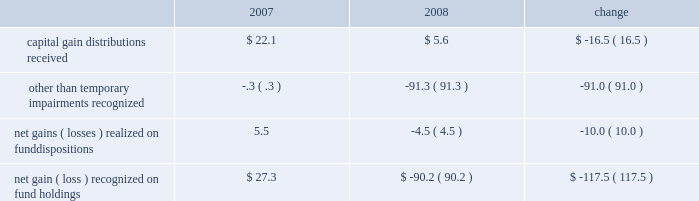Investment advisory revenues earned on the other investment portfolios that we manage decreased $ 3.6 million to $ 522.2 million .
Average assets in these portfolios were $ 142.1 billion during 2008 , up slightly from $ 141.4 billion in 2007 .
These minor changes , each less than 1% ( 1 % ) , are attributable to the timing of declining equity market valuations and cash flows among our separate account and sub-advised portfolios .
Net inflows , primarily from institutional investors , were $ 13.2 billion during 2008 , including the $ 1.3 billion transferred from the retirement funds to target-date trusts .
Decreases in market valuations , net of income , lowered our assets under management in these portfolios by $ 55.3 billion during 2008 .
Administrative fees increased $ 5.8 million to $ 353.9 million , primarily from increased costs of servicing activities for the mutual funds and their investors .
Changes in administrative fees are generally offset by similar changes in related operating expenses that are incurred to provide services to the funds and their investors .
Our largest expense , compensation and related costs , increased $ 18.4 million or 2.3% ( 2.3 % ) from 2007 .
This increase includes $ 37.2 million in salaries resulting from an 8.4% ( 8.4 % ) increase in our average staff count and an increase of our associates 2019 base salaries at the beginning of the year .
At december 31 , 2008 , we employed 5385 associates , up 6.0% ( 6.0 % ) from the end of 2007 , primarily to add capabilities and support increased volume-related activities and other growth over the past few years .
Over the course of 2008 , we slowed the growth of our associate base from earlier plans and the prior year .
We do not expect the number of our associates to increase in 2009 .
We also reduced our annual bonuses $ 27.6 million versus the 2007 year in response to recent and ongoing unfavorable financial market conditions that negatively impacted our operating results .
The balance of the increase is attributable to higher employee benefits and employment- related expenses , including an increase of $ 5.7 million in stock-based compensation .
Entering 2009 , we did not increase the salaries of our highest paid associates .
After higher spending during the first quarter of 2008 versus 2007 , investor sentiment in the uncertain and volatile market environment caused us to reduce advertising and promotion spending , which for the year was down $ 3.8 million from 2007 .
We expect to reduce these expenditures for 2009 versus 2008 , and estimate that spending in the first quarter of 2009 will be down about $ 5 million from the fourth quarter of 2008 .
We vary our level of spending based on market conditions and investor demand as well as our efforts to expand our investor base in the united states and abroad .
Occupancy and facility costs together with depreciation expense increased $ 18 million , or 12% ( 12 % ) compared to 2007 .
We have been expanding and renovating our facilities to accommodate the growth in our associates to meet business demands .
Other operating expenses were up $ 3.3 million from 2007 .
We increased our spending $ 9.8 million , primarily for professional fees and information and other third-party services .
Reductions in travel and charitable contributions partially offset these increases .
Our non-operating investment activity resulted in a net loss of $ 52.3 million in 2008 as compared to a net gain of $ 80.4 million in 2007 .
This change of $ 132.7 million is primarily attributable to losses recognized in 2008 on our investments in sponsored mutual funds , which resulted from declines in financial market values during the year. .
We recognized other than temporary impairments of our investments in sponsored mutual funds because of declines in fair value below cost for an extended period .
The significant declines in fair value below cost that occurred in 2008 were generally attributable to the adverse and ongoing market conditions discussed in the background section on page 18 of this report .
See also the discussion on page 24 of critical accounting policies for other than temporary impairments of available-for-sale securities .
In addition , income from money market and bond fund holdings was $ 19.3 million lower than in 2007 due to the significantly lower interest rate environment of 2008 .
Lower interest rates also led to substantial capital appreciation on our $ 40 million holding of u.s .
Treasury notes that we sold in december 2008 at a $ 2.6 million gain .
Management 2019s discussion & analysis 21 .
What was the percentage change in capital gain distributions received between 2007 and 2008? 
Computations: (-16.5 / 22.1)
Answer: -0.74661. Investment advisory revenues earned on the other investment portfolios that we manage decreased $ 3.6 million to $ 522.2 million .
Average assets in these portfolios were $ 142.1 billion during 2008 , up slightly from $ 141.4 billion in 2007 .
These minor changes , each less than 1% ( 1 % ) , are attributable to the timing of declining equity market valuations and cash flows among our separate account and sub-advised portfolios .
Net inflows , primarily from institutional investors , were $ 13.2 billion during 2008 , including the $ 1.3 billion transferred from the retirement funds to target-date trusts .
Decreases in market valuations , net of income , lowered our assets under management in these portfolios by $ 55.3 billion during 2008 .
Administrative fees increased $ 5.8 million to $ 353.9 million , primarily from increased costs of servicing activities for the mutual funds and their investors .
Changes in administrative fees are generally offset by similar changes in related operating expenses that are incurred to provide services to the funds and their investors .
Our largest expense , compensation and related costs , increased $ 18.4 million or 2.3% ( 2.3 % ) from 2007 .
This increase includes $ 37.2 million in salaries resulting from an 8.4% ( 8.4 % ) increase in our average staff count and an increase of our associates 2019 base salaries at the beginning of the year .
At december 31 , 2008 , we employed 5385 associates , up 6.0% ( 6.0 % ) from the end of 2007 , primarily to add capabilities and support increased volume-related activities and other growth over the past few years .
Over the course of 2008 , we slowed the growth of our associate base from earlier plans and the prior year .
We do not expect the number of our associates to increase in 2009 .
We also reduced our annual bonuses $ 27.6 million versus the 2007 year in response to recent and ongoing unfavorable financial market conditions that negatively impacted our operating results .
The balance of the increase is attributable to higher employee benefits and employment- related expenses , including an increase of $ 5.7 million in stock-based compensation .
Entering 2009 , we did not increase the salaries of our highest paid associates .
After higher spending during the first quarter of 2008 versus 2007 , investor sentiment in the uncertain and volatile market environment caused us to reduce advertising and promotion spending , which for the year was down $ 3.8 million from 2007 .
We expect to reduce these expenditures for 2009 versus 2008 , and estimate that spending in the first quarter of 2009 will be down about $ 5 million from the fourth quarter of 2008 .
We vary our level of spending based on market conditions and investor demand as well as our efforts to expand our investor base in the united states and abroad .
Occupancy and facility costs together with depreciation expense increased $ 18 million , or 12% ( 12 % ) compared to 2007 .
We have been expanding and renovating our facilities to accommodate the growth in our associates to meet business demands .
Other operating expenses were up $ 3.3 million from 2007 .
We increased our spending $ 9.8 million , primarily for professional fees and information and other third-party services .
Reductions in travel and charitable contributions partially offset these increases .
Our non-operating investment activity resulted in a net loss of $ 52.3 million in 2008 as compared to a net gain of $ 80.4 million in 2007 .
This change of $ 132.7 million is primarily attributable to losses recognized in 2008 on our investments in sponsored mutual funds , which resulted from declines in financial market values during the year. .
We recognized other than temporary impairments of our investments in sponsored mutual funds because of declines in fair value below cost for an extended period .
The significant declines in fair value below cost that occurred in 2008 were generally attributable to the adverse and ongoing market conditions discussed in the background section on page 18 of this report .
See also the discussion on page 24 of critical accounting policies for other than temporary impairments of available-for-sale securities .
In addition , income from money market and bond fund holdings was $ 19.3 million lower than in 2007 due to the significantly lower interest rate environment of 2008 .
Lower interest rates also led to substantial capital appreciation on our $ 40 million holding of u.s .
Treasury notes that we sold in december 2008 at a $ 2.6 million gain .
Management 2019s discussion & analysis 21 .
What was the percentage change in net gains ( losses ) realized on fund dispositions between 2007 and 2008? 
Computations: (-10.0 / 5.5)
Answer: -1.81818. 